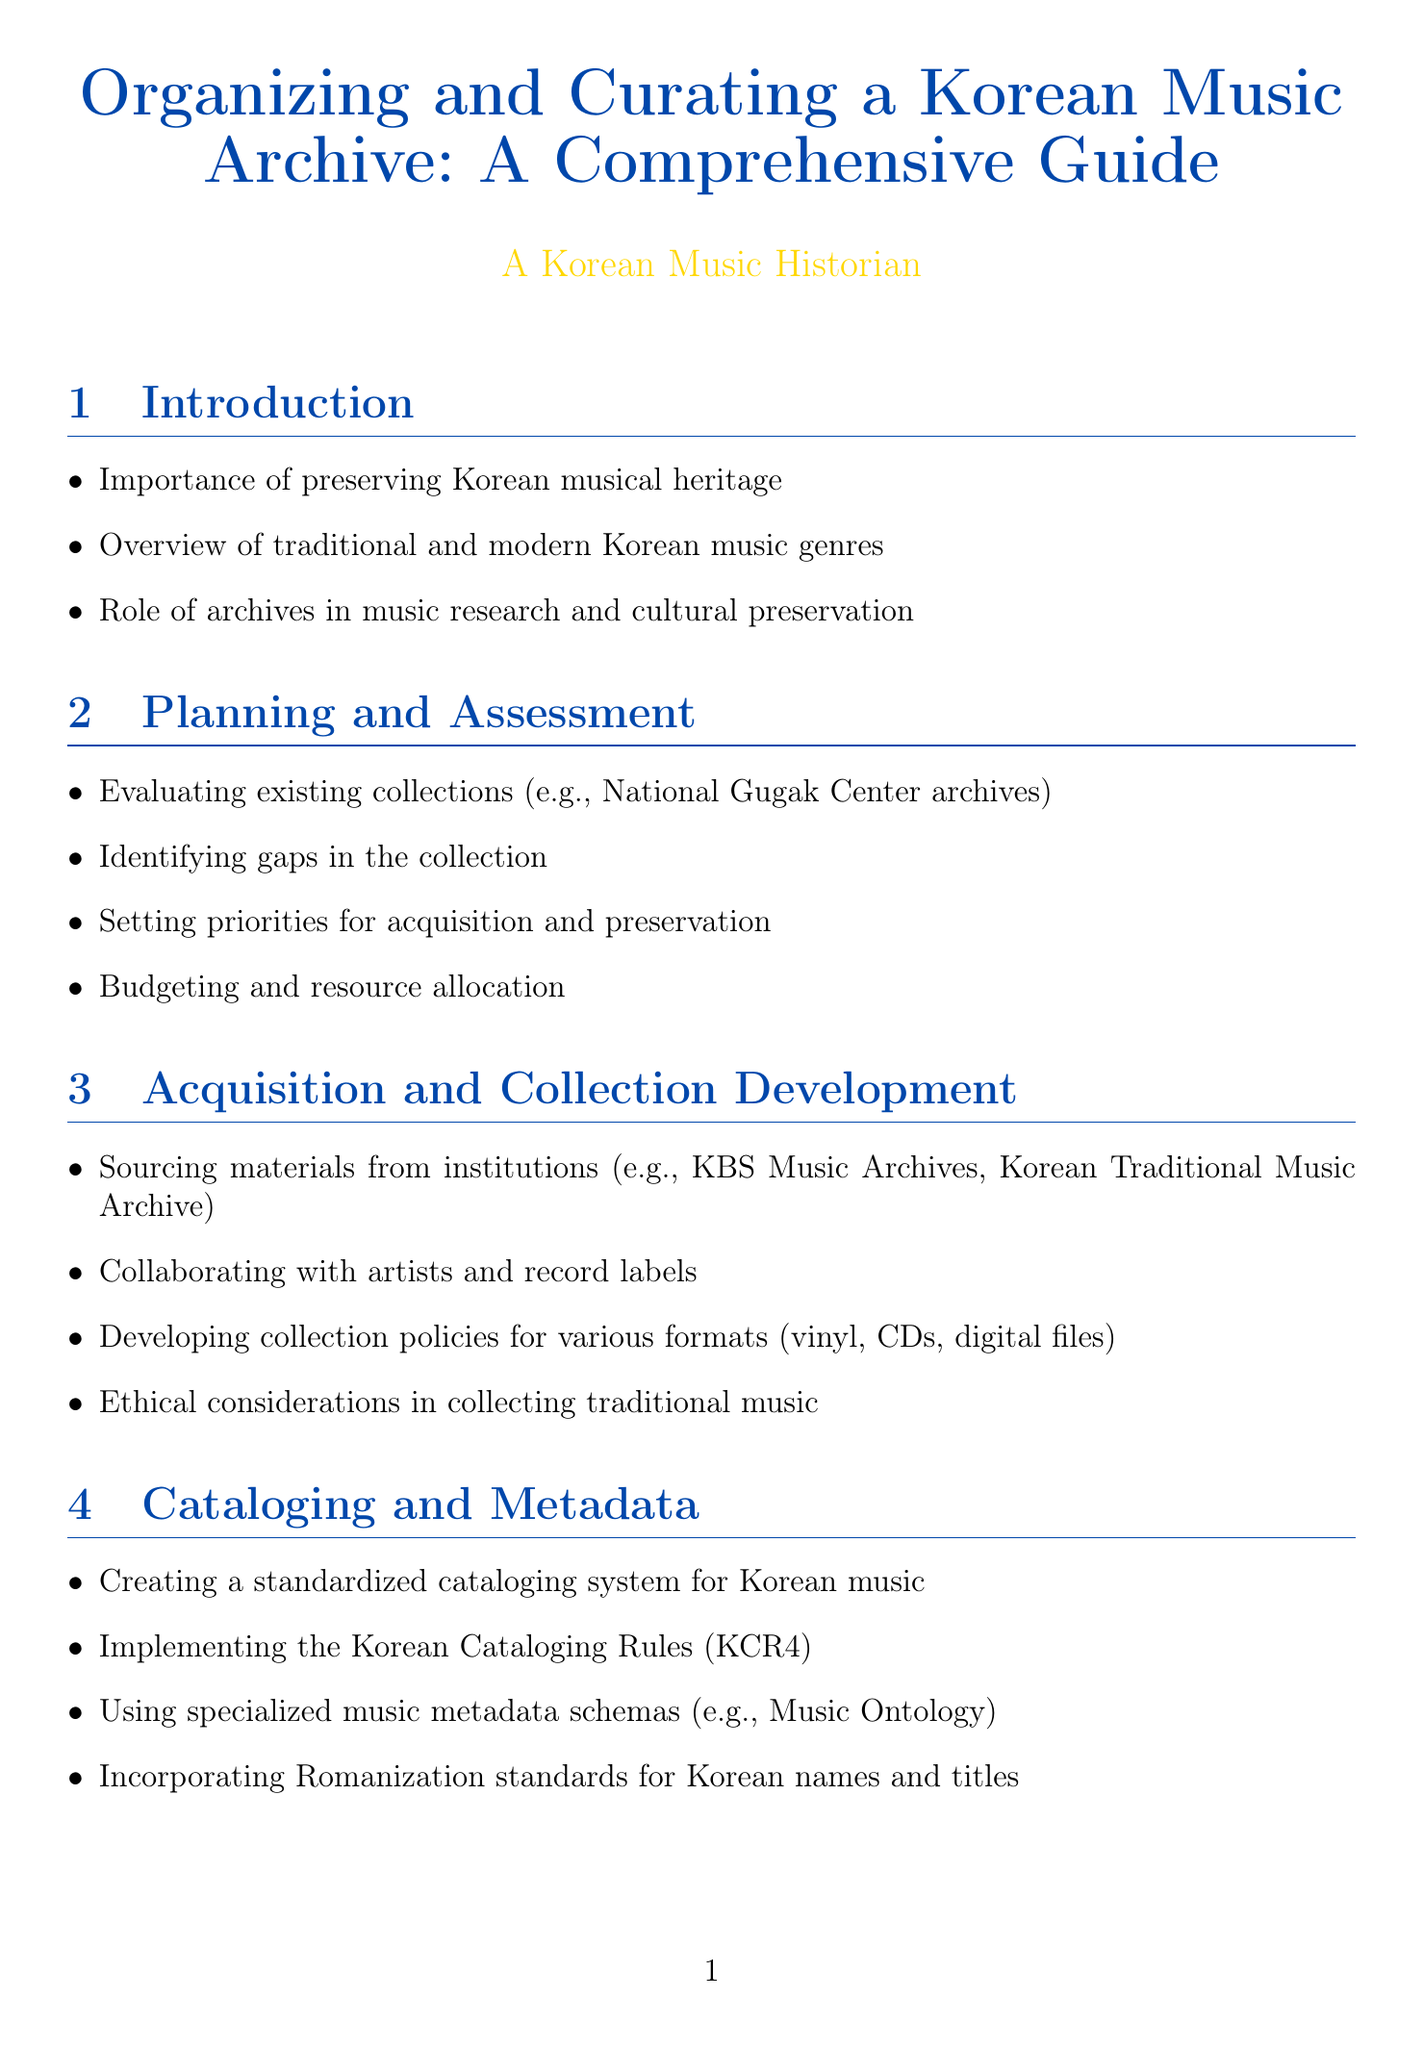What is the title of the document? The title is prominently displayed at the beginning of the document.
Answer: Organizing and Curating a Korean Music Archive: A Comprehensive Guide How many sections are in the document? The number of sections can be counted from the list provided in the document.
Answer: 10 What is one institution mentioned for collaboration in the Acquisition and Collection Development section? An example of an institution mentioned in that section can be found in the list of sourcing materials.
Answer: KBS Music Archives What does OAIS stand for in the context of digital preservation? The abbreviation is defined within the Digital Preservation Techniques section.
Answer: Open Archival Information System What is the purpose of implementing quality control procedures in the digitization process? Quality control is necessary to ensure the integrity and quality of the materials being digitized.
Answer: To ensure quality Which traditional genre is mentioned in the Specialized Considerations for Korean Music section? Specific genres are listed in that section that focuses on traditional music practices.
Answer: Aak How can institutions organize exhibitions according to the Access and Outreach section? The section discusses various activities for engaging the public and researchers.
Answer: Organizing exhibitions What kind of equipment is mentioned for audio digitization? High-quality equipment is specified for the digitization processes described.
Answer: TASCAM DA-3000 What are the two main types of preservation discussed in the document? The document outlines both digital and physical preservation aspects.
Answer: Digital and Physical What is a consideration when developing collection policies? The document indicates various factors to think about when forming policies for collections.
Answer: Ethical considerations 